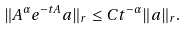<formula> <loc_0><loc_0><loc_500><loc_500>\| A ^ { \alpha } e ^ { - t A } a \| _ { r } \leq C t ^ { - \alpha } \| a \| _ { r } .</formula> 